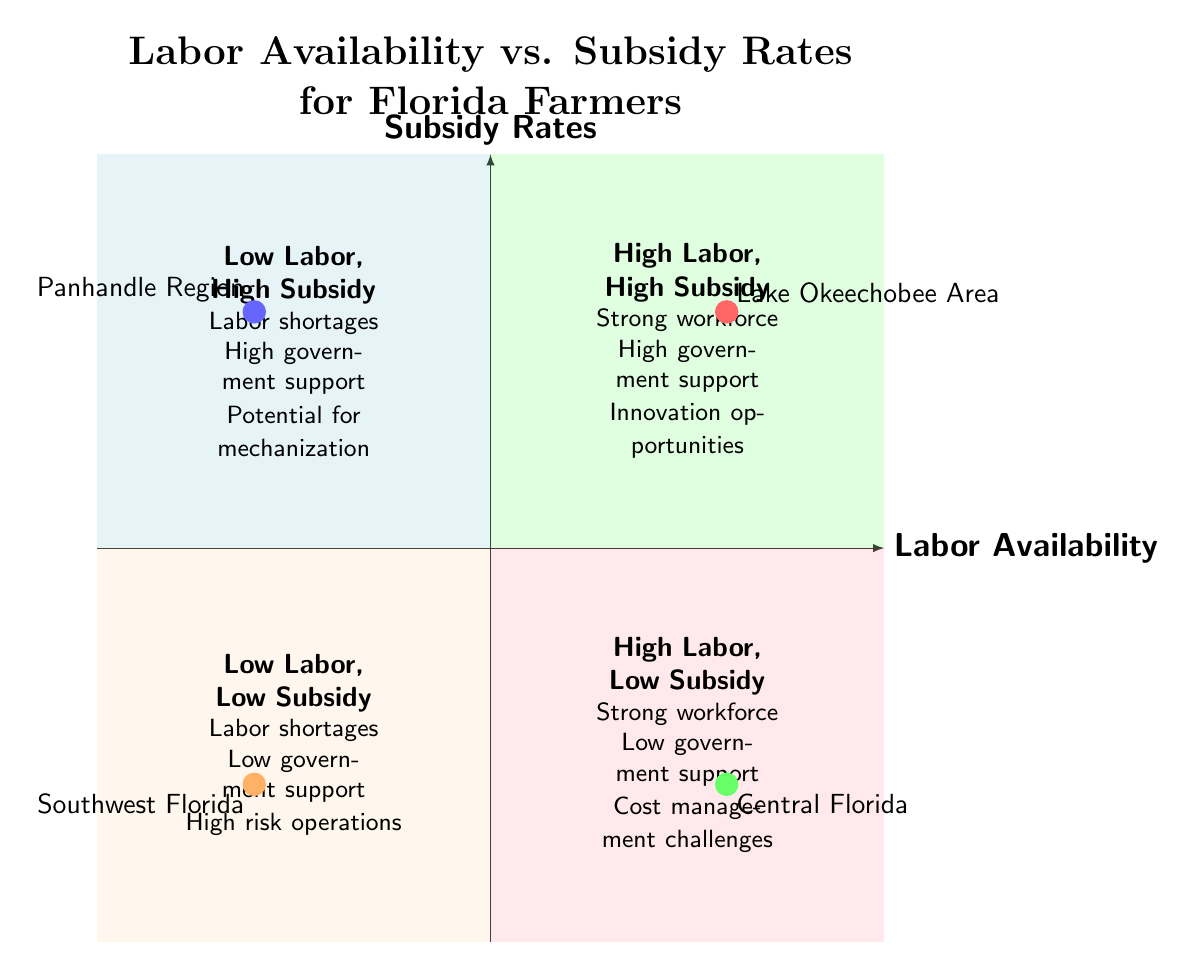What is the quadrant for Lake Okeechobee Area? The Lake Okeechobee Area is represented in the diagram as having high labor availability and high subsidy rates, which corresponds to the "High Labor, High Subsidy" quadrant.
Answer: High Labor, High Subsidy How many quadrants are in the chart? The chart is divided into four distinct quadrants, based on the combinations of labor availability and subsidy rates.
Answer: Four What characteristics are associated with Low Labor, High Subsidy quadrant? The characteristics listed in the "Low Labor, High Subsidy" quadrant include labor shortages, high government support, and potential for mechanization.
Answer: Labor shortages, high government support, potential for mechanization What is the subsidy rate for Central Florida? According to the data presented on the chart, Central Florida falls into the "High Labor, Low Subsidy" category, indicating a low subsidy rate for this region.
Answer: Low Which region has a strong workforce but low government support? The Central Florida region shows high labor availability but is categorized under the "Low Subsidy" designation, meaning it has a strong workforce yet faces low government support.
Answer: Central Florida What point of interest is found in the Low Labor, Low Subsidy quadrant? The Southwest Florida region is depicted in the diagram as having both low labor availability and low subsidy rates, placing it within the "Low Labor, Low Subsidy" quadrant.
Answer: Southwest Florida Which quadrant has strong workforce and high governmental support? The "High Labor, High Subsidy" quadrant showcases regions that have a strong workforce along with substantial government support, such as the Lake Okeechobee Area.
Answer: High Labor, High Subsidy How does the Panhandle Region relate to government support? The Panhandle Region, located in the "Low Labor, High Subsidy" quadrant, indicates a condition of labor shortages but still enjoys high government support.
Answer: High government support What factor is represented in the y-axis of the chart? The y-axis of the chart represents subsidy rates, which measures the amount of government support available to farmers in relation to their labor availability.
Answer: Subsidy Rates 